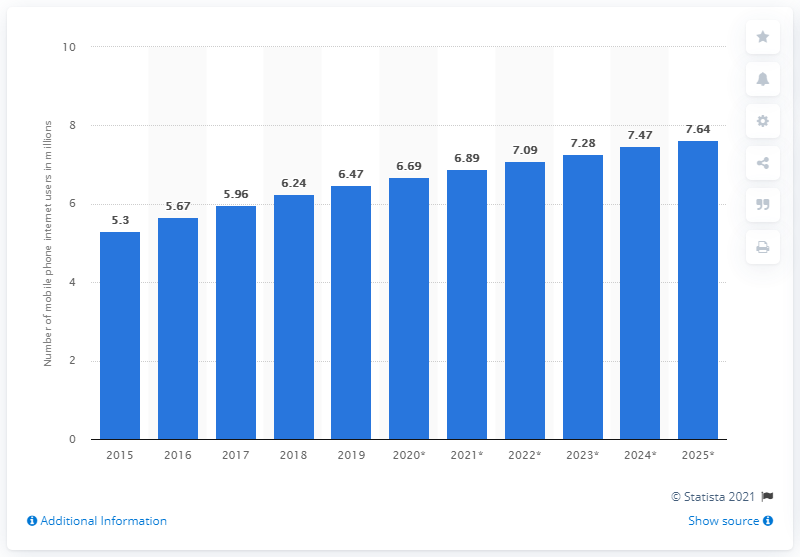Highlight a few significant elements in this photo. By 2025, it is estimated that there will be approximately 7.64 million mobile internet users in Israel. As of 2025, it is estimated that there will be approximately 7.64 million smartphone users in Israel. 